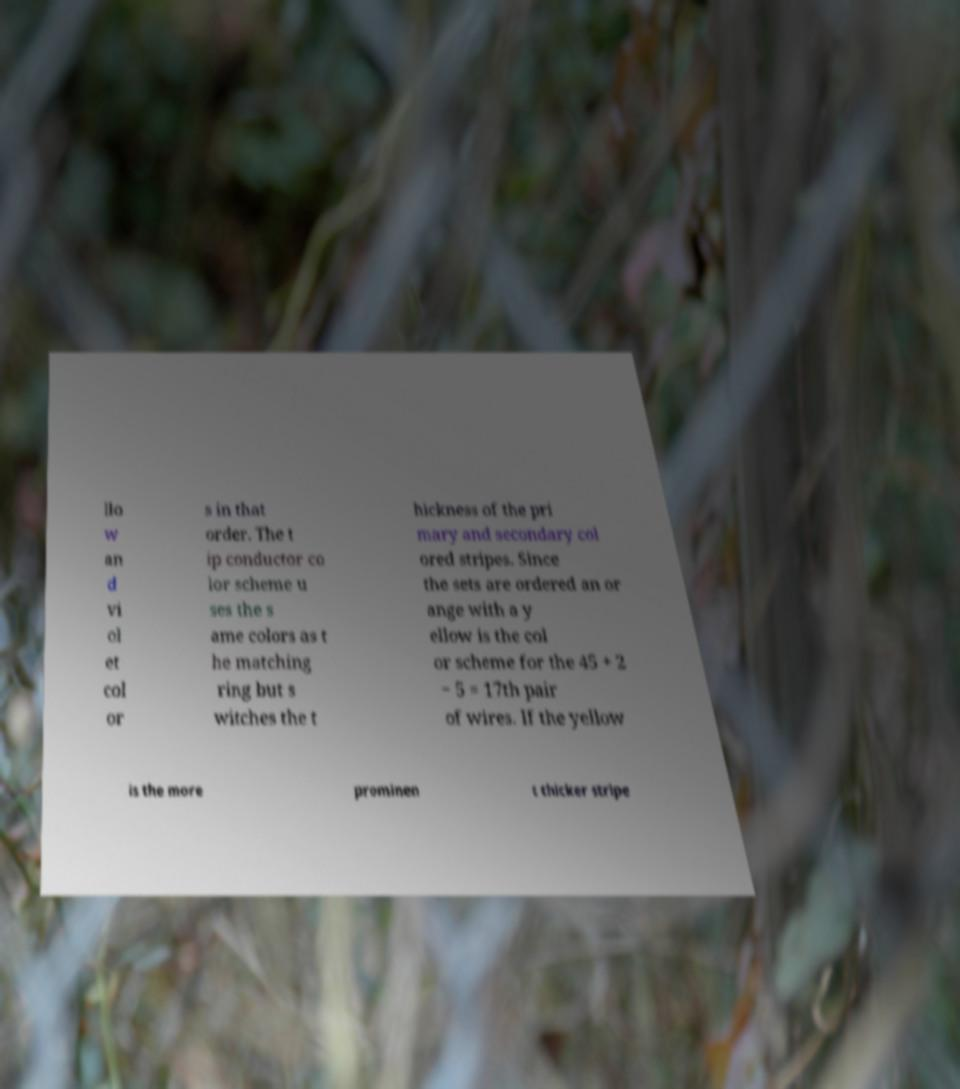I need the written content from this picture converted into text. Can you do that? llo w an d vi ol et col or s in that order. The t ip conductor co lor scheme u ses the s ame colors as t he matching ring but s witches the t hickness of the pri mary and secondary col ored stripes. Since the sets are ordered an or ange with a y ellow is the col or scheme for the 45 + 2 − 5 = 17th pair of wires. If the yellow is the more prominen t thicker stripe 